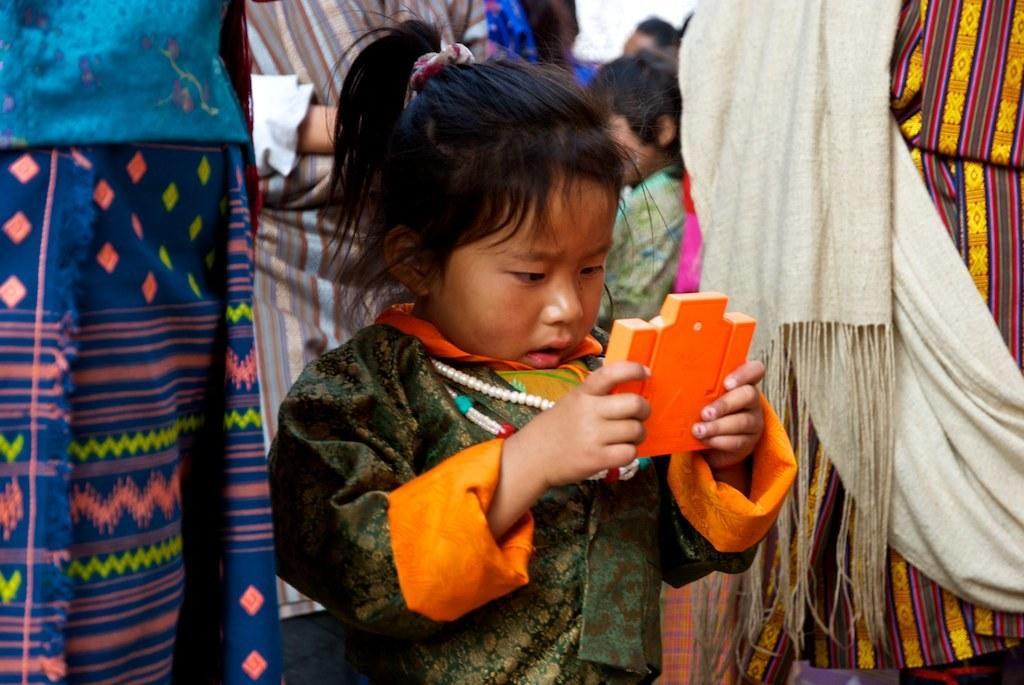Could you give a brief overview of what you see in this image? In the center of the image we can see a girl standing and holding an object. In the background there are people. 